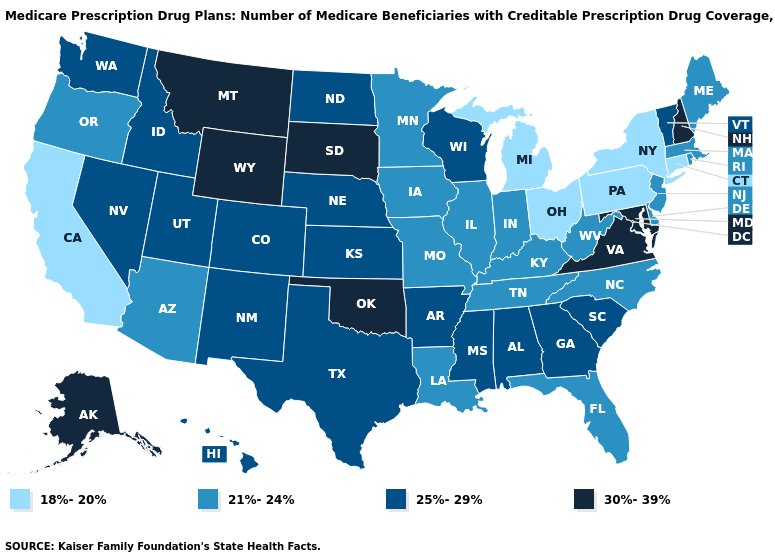What is the lowest value in states that border Vermont?
Concise answer only. 18%-20%. What is the lowest value in states that border Delaware?
Quick response, please. 18%-20%. Is the legend a continuous bar?
Quick response, please. No. Among the states that border Wisconsin , does Michigan have the highest value?
Be succinct. No. What is the value of Minnesota?
Concise answer only. 21%-24%. Which states hav the highest value in the South?
Give a very brief answer. Maryland, Oklahoma, Virginia. What is the highest value in the USA?
Keep it brief. 30%-39%. What is the value of New Jersey?
Short answer required. 21%-24%. What is the value of Georgia?
Write a very short answer. 25%-29%. Which states have the highest value in the USA?
Give a very brief answer. Alaska, Maryland, Montana, New Hampshire, Oklahoma, South Dakota, Virginia, Wyoming. Name the states that have a value in the range 30%-39%?
Quick response, please. Alaska, Maryland, Montana, New Hampshire, Oklahoma, South Dakota, Virginia, Wyoming. Does Washington have the lowest value in the West?
Short answer required. No. Name the states that have a value in the range 18%-20%?
Quick response, please. California, Connecticut, Michigan, New York, Ohio, Pennsylvania. Name the states that have a value in the range 21%-24%?
Be succinct. Arizona, Delaware, Florida, Illinois, Indiana, Iowa, Kentucky, Louisiana, Maine, Massachusetts, Minnesota, Missouri, New Jersey, North Carolina, Oregon, Rhode Island, Tennessee, West Virginia. What is the value of Vermont?
Give a very brief answer. 25%-29%. 